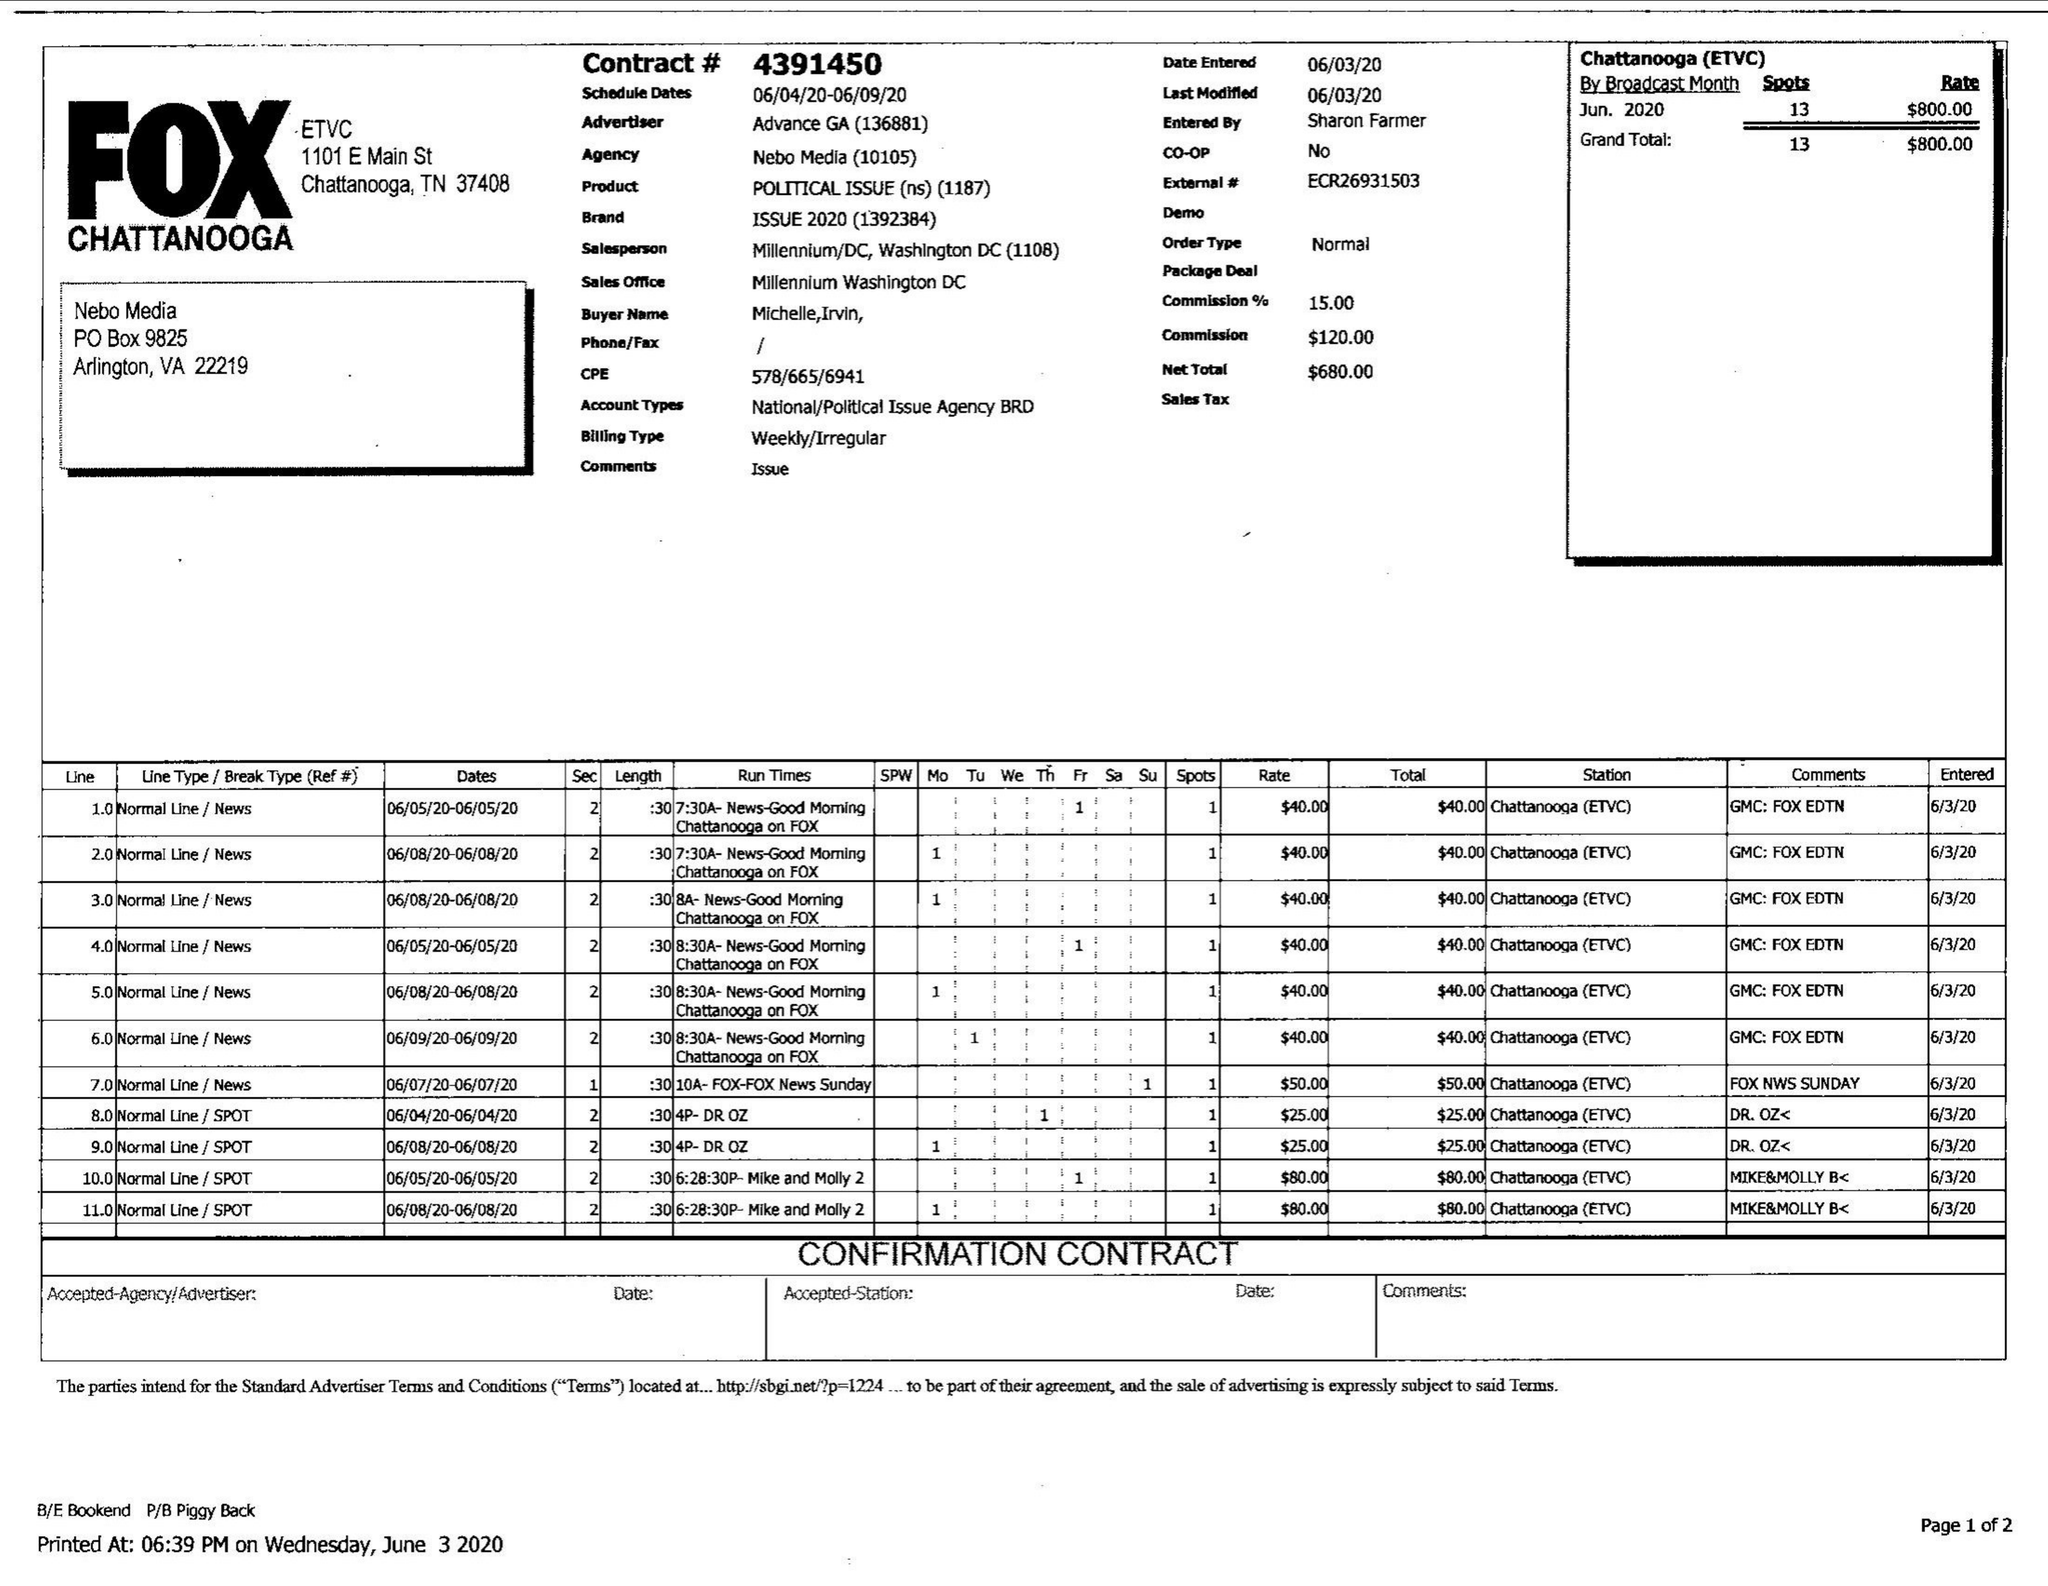What is the value for the flight_to?
Answer the question using a single word or phrase. 06/09/20 